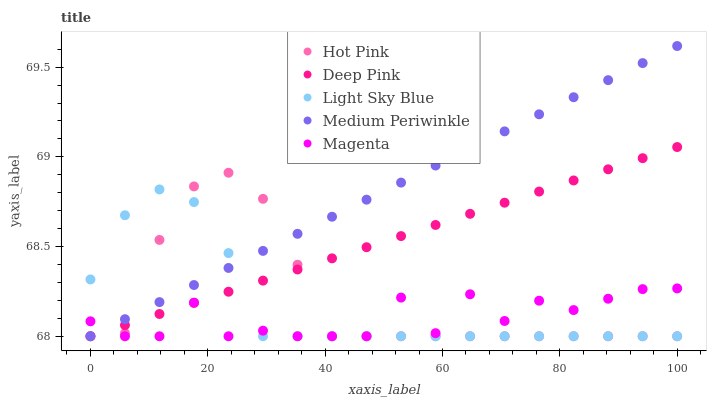Does Magenta have the minimum area under the curve?
Answer yes or no. Yes. Does Medium Periwinkle have the maximum area under the curve?
Answer yes or no. Yes. Does Hot Pink have the minimum area under the curve?
Answer yes or no. No. Does Hot Pink have the maximum area under the curve?
Answer yes or no. No. Is Medium Periwinkle the smoothest?
Answer yes or no. Yes. Is Magenta the roughest?
Answer yes or no. Yes. Is Hot Pink the smoothest?
Answer yes or no. No. Is Hot Pink the roughest?
Answer yes or no. No. Does Magenta have the lowest value?
Answer yes or no. Yes. Does Medium Periwinkle have the highest value?
Answer yes or no. Yes. Does Hot Pink have the highest value?
Answer yes or no. No. Does Hot Pink intersect Light Sky Blue?
Answer yes or no. Yes. Is Hot Pink less than Light Sky Blue?
Answer yes or no. No. Is Hot Pink greater than Light Sky Blue?
Answer yes or no. No. 